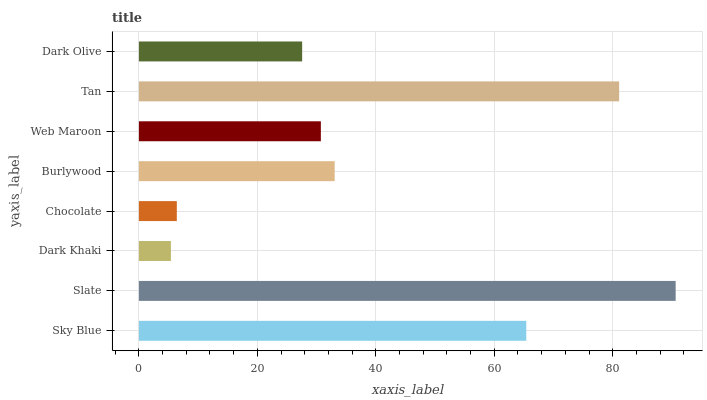Is Dark Khaki the minimum?
Answer yes or no. Yes. Is Slate the maximum?
Answer yes or no. Yes. Is Slate the minimum?
Answer yes or no. No. Is Dark Khaki the maximum?
Answer yes or no. No. Is Slate greater than Dark Khaki?
Answer yes or no. Yes. Is Dark Khaki less than Slate?
Answer yes or no. Yes. Is Dark Khaki greater than Slate?
Answer yes or no. No. Is Slate less than Dark Khaki?
Answer yes or no. No. Is Burlywood the high median?
Answer yes or no. Yes. Is Web Maroon the low median?
Answer yes or no. Yes. Is Chocolate the high median?
Answer yes or no. No. Is Burlywood the low median?
Answer yes or no. No. 